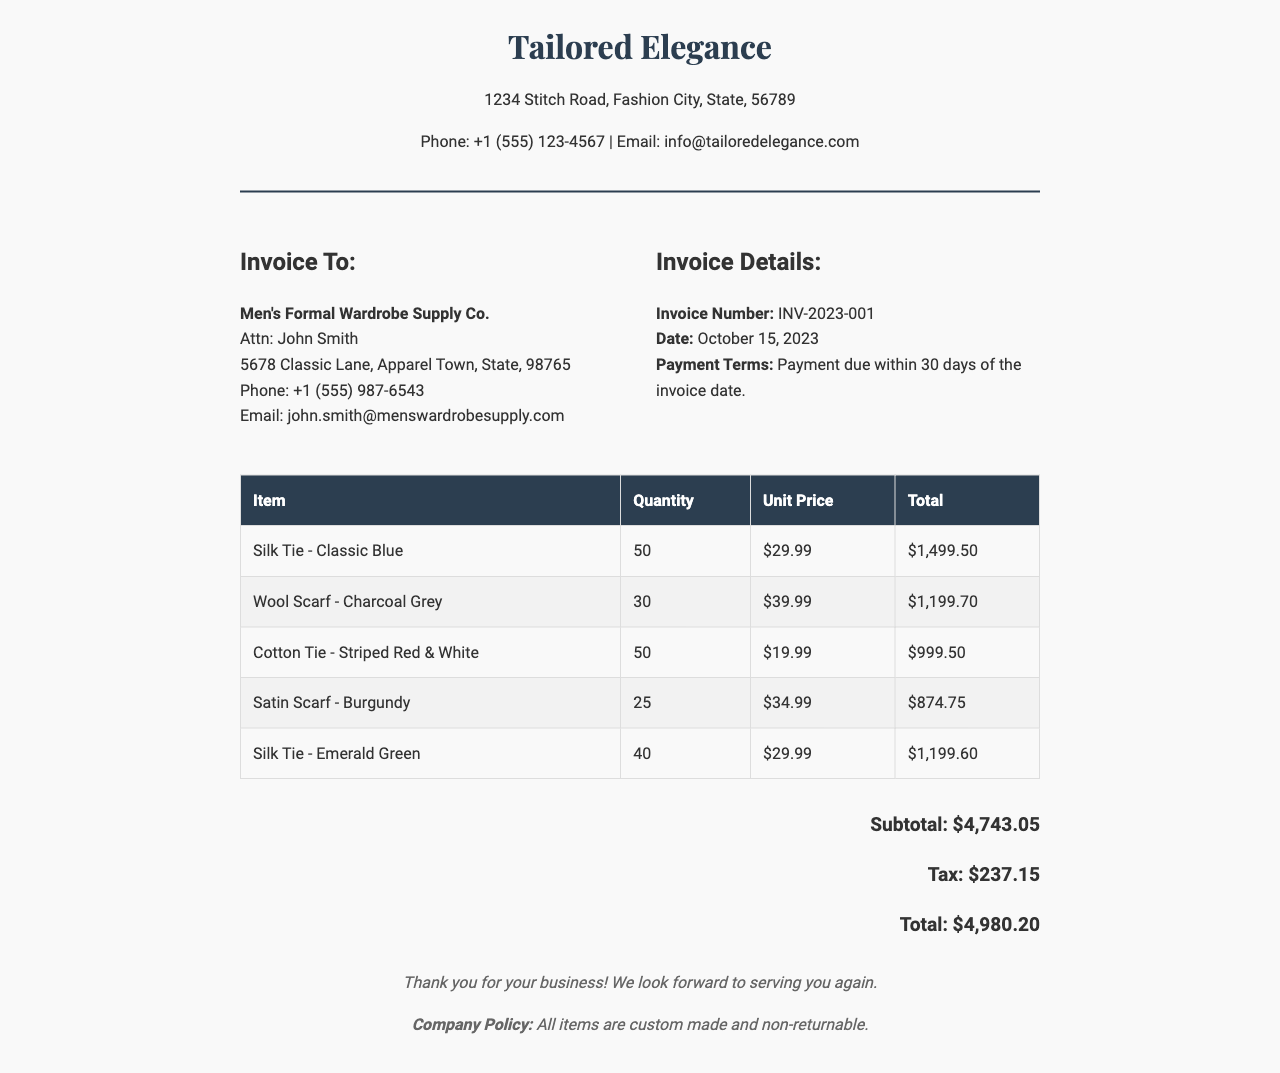What is the invoice number? The invoice number is mentioned in the invoice details section, which is INV-2023-001.
Answer: INV-2023-001 What is the date of the invoice? The date of the invoice is specified in the invoice details section as October 15, 2023.
Answer: October 15, 2023 Who is the invoice addressed to? The invoice is addressed to Men's Formal Wardrobe Supply Co., with John Smith as the contact person.
Answer: Men's Formal Wardrobe Supply Co How many Silk Ties - Classic Blue were ordered? The quantity of Silk Ties - Classic Blue ordered is listed as 50 in the items table.
Answer: 50 What is the total amount before tax? The subtotal before tax is provided in the document as $4,743.05.
Answer: $4,743.05 What is the total cost including tax? The total cost including tax is noted at the bottom of the invoice as $4,980.20.
Answer: $4,980.20 What type of items were purchased in this invoice? The items purchased are gender-specific accessories, including ties and scarves.
Answer: Ties and scarves How many items have a unit price of $34.99? The document lists one item, a Satin Scarf - Burgundy, with a unit price of $34.99, with a quantity of 25.
Answer: 1 What is the company policy mentioned in the footer? The company policy states that all items are custom made and non-returnable.
Answer: Custom made and non-returnable 